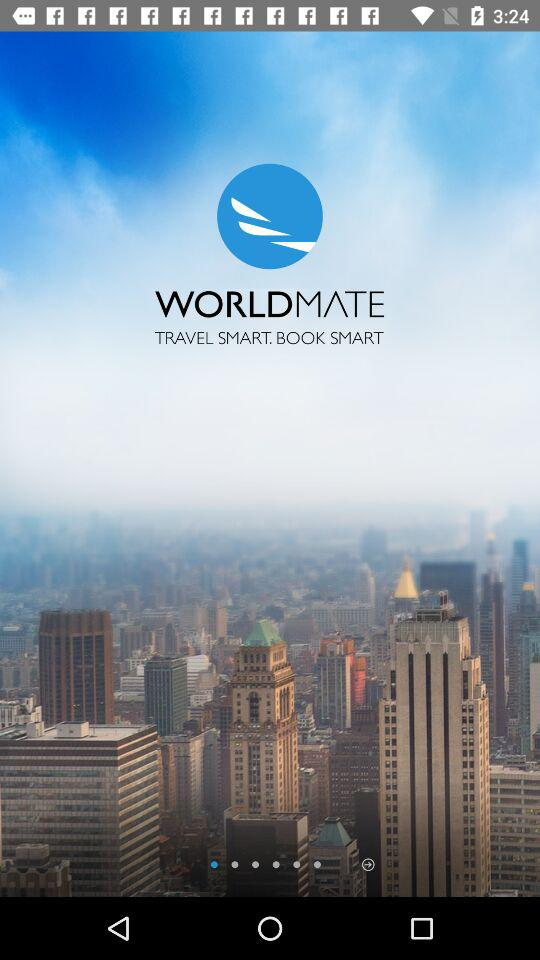What is the application name? The application name is "WORLD MATE". 